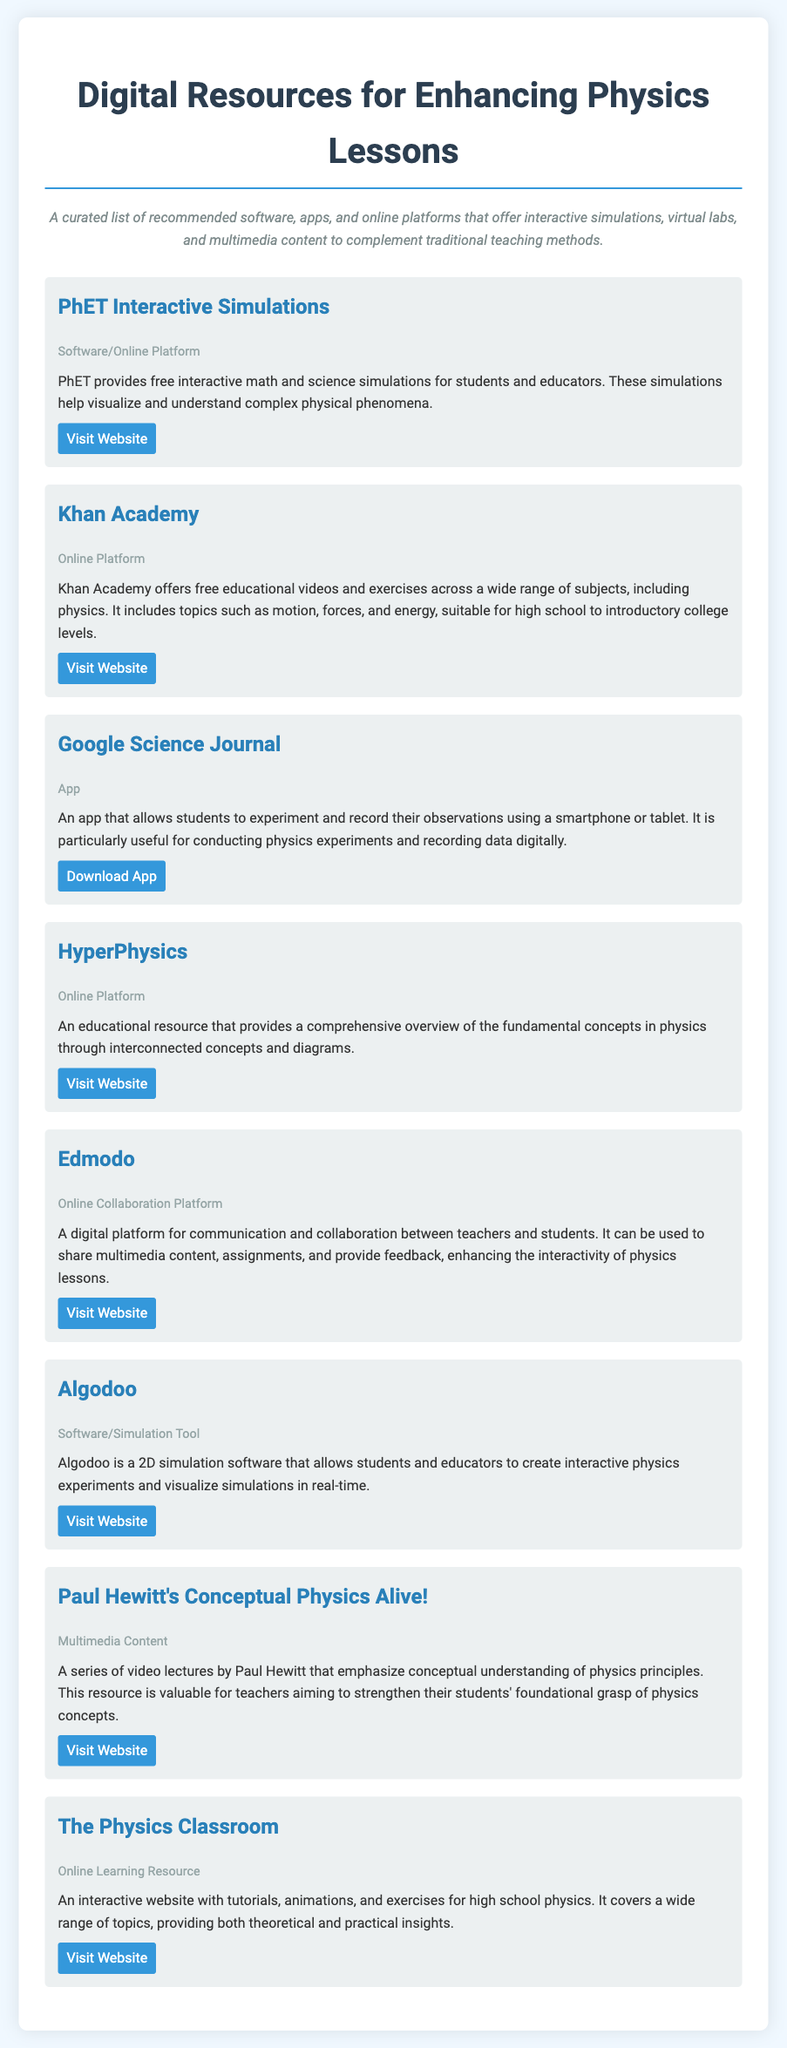What is the title of the document? The title appears at the top of the document and provides information about its focus on educational resources.
Answer: Digital Resources for Enhancing Physics Lessons How many resources are listed in the document? The number of individual resources provided can be counted from the main content sections.
Answer: Eight What resource offers interactive math and science simulations? This information is derived from the description of the specific resource in the document.
Answer: PhET Interactive Simulations What type of platform is Khan Academy categorized as? The categorization of Khan Academy is stated in the document, indicating its function.
Answer: Online Platform Which app allows students to experiment and record observations? This question seeks to identify the app mentioned in the document that has this capability.
Answer: Google Science Journal What is the primary focus of Paul Hewitt's Conceptual Physics Alive!? The document mentions the content focus for this multimedia resource, which is aimed at a specific educational aspect.
Answer: Conceptual understanding What kind of content does The Physics Classroom provide? This asks for the type of educational content available as described in the document.
Answer: Interactive website with tutorials, animations, and exercises What is the main purpose of Edmodo as mentioned in the document? The explanation of Edmodo's function gives insight into its use in physics lessons.
Answer: Communication and collaboration between teachers and students 